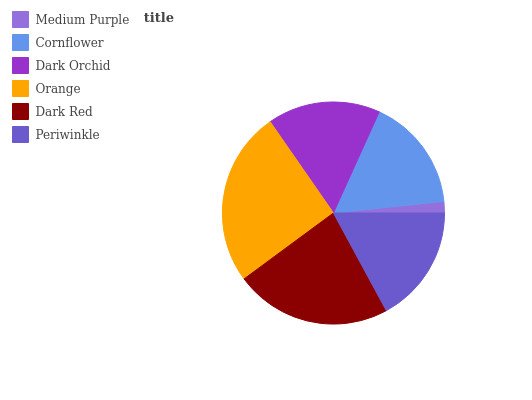Is Medium Purple the minimum?
Answer yes or no. Yes. Is Orange the maximum?
Answer yes or no. Yes. Is Cornflower the minimum?
Answer yes or no. No. Is Cornflower the maximum?
Answer yes or no. No. Is Cornflower greater than Medium Purple?
Answer yes or no. Yes. Is Medium Purple less than Cornflower?
Answer yes or no. Yes. Is Medium Purple greater than Cornflower?
Answer yes or no. No. Is Cornflower less than Medium Purple?
Answer yes or no. No. Is Periwinkle the high median?
Answer yes or no. Yes. Is Cornflower the low median?
Answer yes or no. Yes. Is Medium Purple the high median?
Answer yes or no. No. Is Medium Purple the low median?
Answer yes or no. No. 